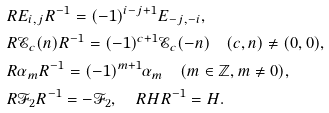<formula> <loc_0><loc_0><loc_500><loc_500>& R E _ { i , j } R ^ { - 1 } = ( - 1 ) ^ { i - j + 1 } E _ { - j , - i } , \\ & R { \mathcal { E } } _ { c } ( n ) R ^ { - 1 } = ( - 1 ) ^ { c + 1 } { \mathcal { E } } _ { c } ( - n ) \quad ( c , n ) \neq ( 0 , 0 ) , \\ & R \alpha _ { m } R ^ { - 1 } = ( - 1 ) ^ { m + 1 } \alpha _ { m } \quad ( m \in \mathbb { Z } , m \neq 0 ) , \\ & R { \mathcal { F } } _ { 2 } R ^ { - 1 } = - { \mathcal { F } } _ { 2 } , \quad R H R ^ { - 1 } = H .</formula> 